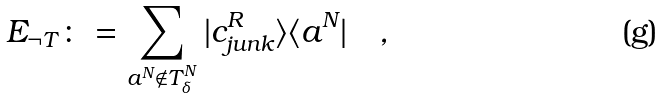Convert formula to latex. <formula><loc_0><loc_0><loc_500><loc_500>E _ { \neg T } \colon = \sum _ { a ^ { N } \notin T _ { \delta } ^ { N } } | c _ { j u n k } ^ { R } \rangle \langle a ^ { N } | \quad ,</formula> 